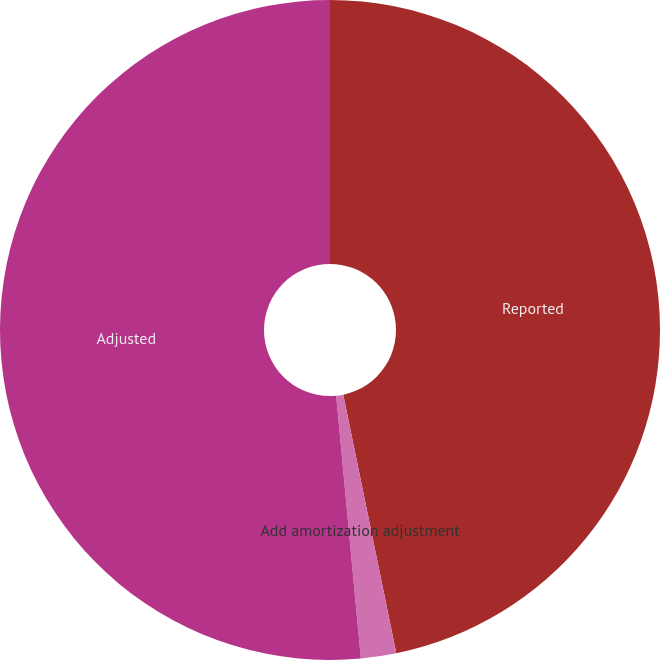<chart> <loc_0><loc_0><loc_500><loc_500><pie_chart><fcel>Reported<fcel>Add amortization adjustment<fcel>Adjusted<nl><fcel>46.78%<fcel>1.73%<fcel>51.49%<nl></chart> 